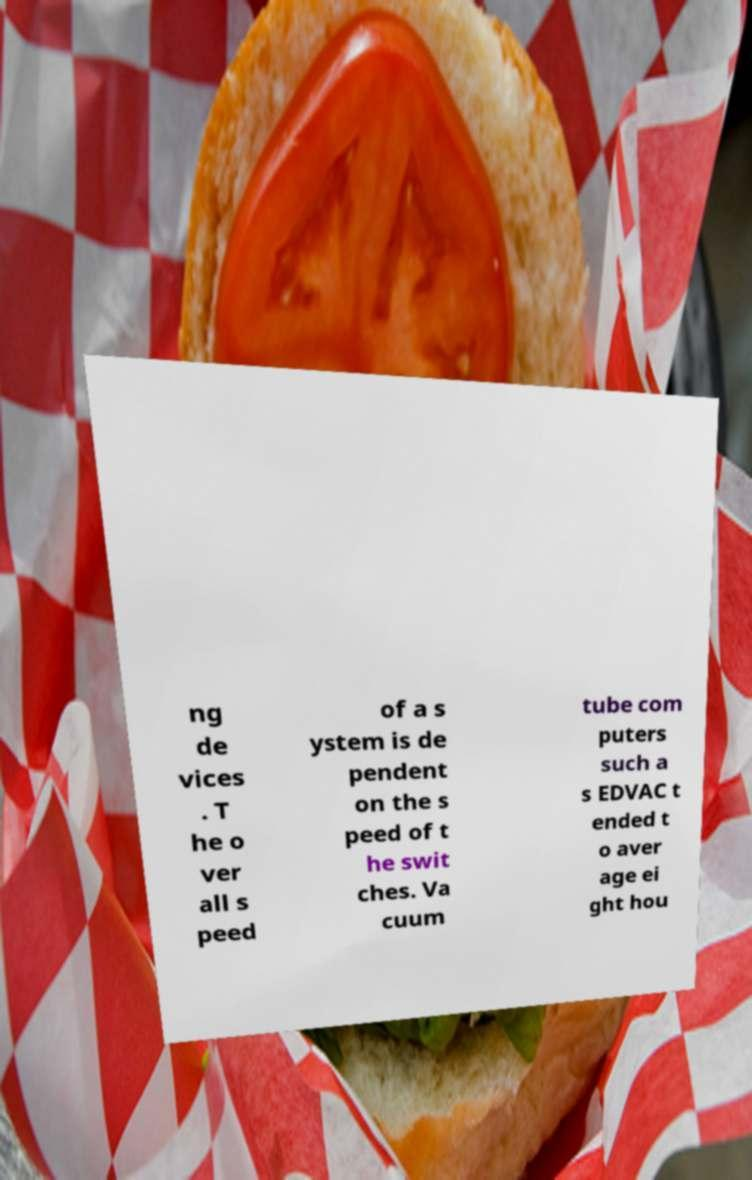Please identify and transcribe the text found in this image. ng de vices . T he o ver all s peed of a s ystem is de pendent on the s peed of t he swit ches. Va cuum tube com puters such a s EDVAC t ended t o aver age ei ght hou 